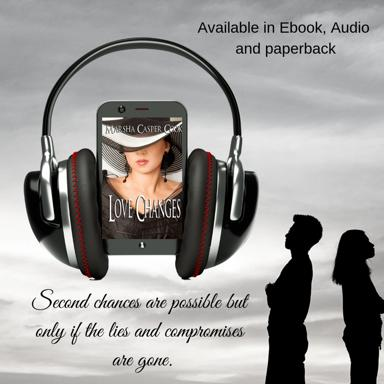Who is the author of the content mentioned in the image? The image reveals that 'Love Changes' is authored by Sha Casper, whose name is prominently featured on the cover art of the novel, though one should note that author names can be depicted in various stylistic manners. 